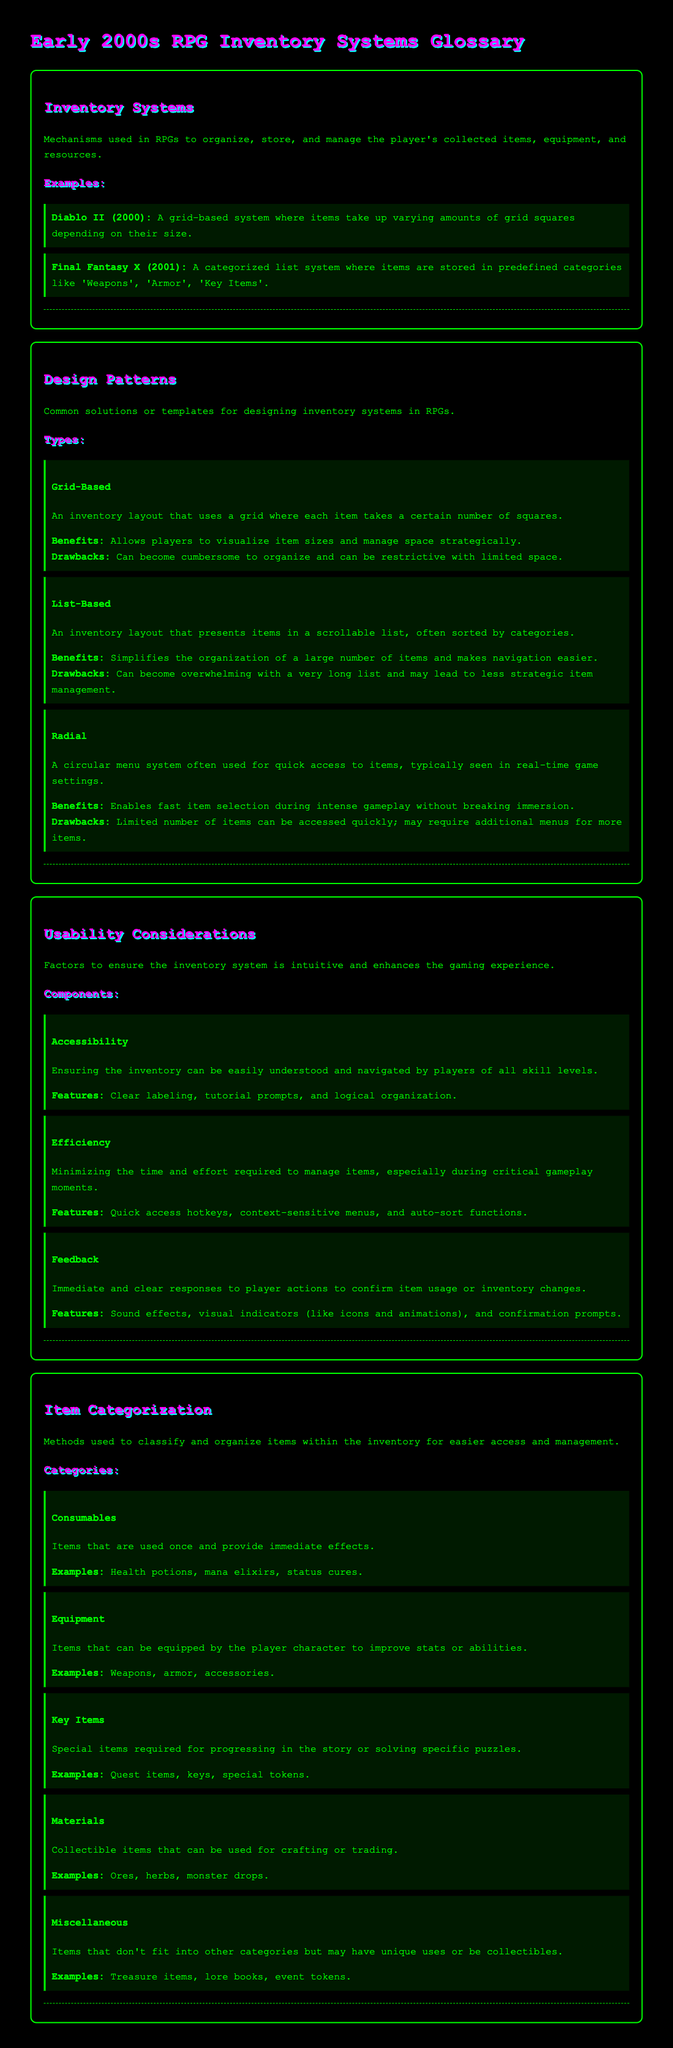What is the title of the document? The title of the document is specified in the head section as "Early 2000s RPG Inventory Systems Glossary."
Answer: Early 2000s RPG Inventory Systems Glossary What is an example of a grid-based inventory system? The document provides "Diablo II (2000)" as an example of a grid-based inventory system.
Answer: Diablo II (2000) What type of inventory system uses a circular menu? The document describes the "Radial" type as a circular menu system.
Answer: Radial What feature is emphasized under Accessibility? The document mentions "Clear labeling" as a feature of Accessibility.
Answer: Clear labeling Which category includes health potions? The document lists health potions under "Consumables."
Answer: Consumables How many types of design patterns are mentioned in the document? The document outlines three types of design patterns: Grid-Based, List-Based, and Radial.
Answer: Three What are items classified as that do not fit into other categories? The document refers to these items as "Miscellaneous."
Answer: Miscellaneous What is the main purpose of the Usability Considerations section? The section focuses on factors to enhance the gaming experience with the inventory system.
Answer: Enhance the gaming experience What is an example of a key item? The document provides "Quest items" as an example of a key item.
Answer: Quest items 